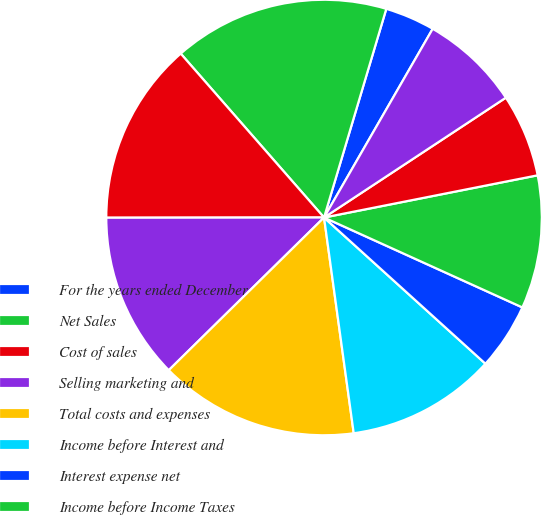Convert chart to OTSL. <chart><loc_0><loc_0><loc_500><loc_500><pie_chart><fcel>For the years ended December<fcel>Net Sales<fcel>Cost of sales<fcel>Selling marketing and<fcel>Total costs and expenses<fcel>Income before Interest and<fcel>Interest expense net<fcel>Income before Income Taxes<fcel>Provision for income taxes<fcel>Accounting Change<nl><fcel>3.7%<fcel>16.05%<fcel>13.58%<fcel>12.35%<fcel>14.81%<fcel>11.11%<fcel>4.94%<fcel>9.88%<fcel>6.17%<fcel>7.41%<nl></chart> 